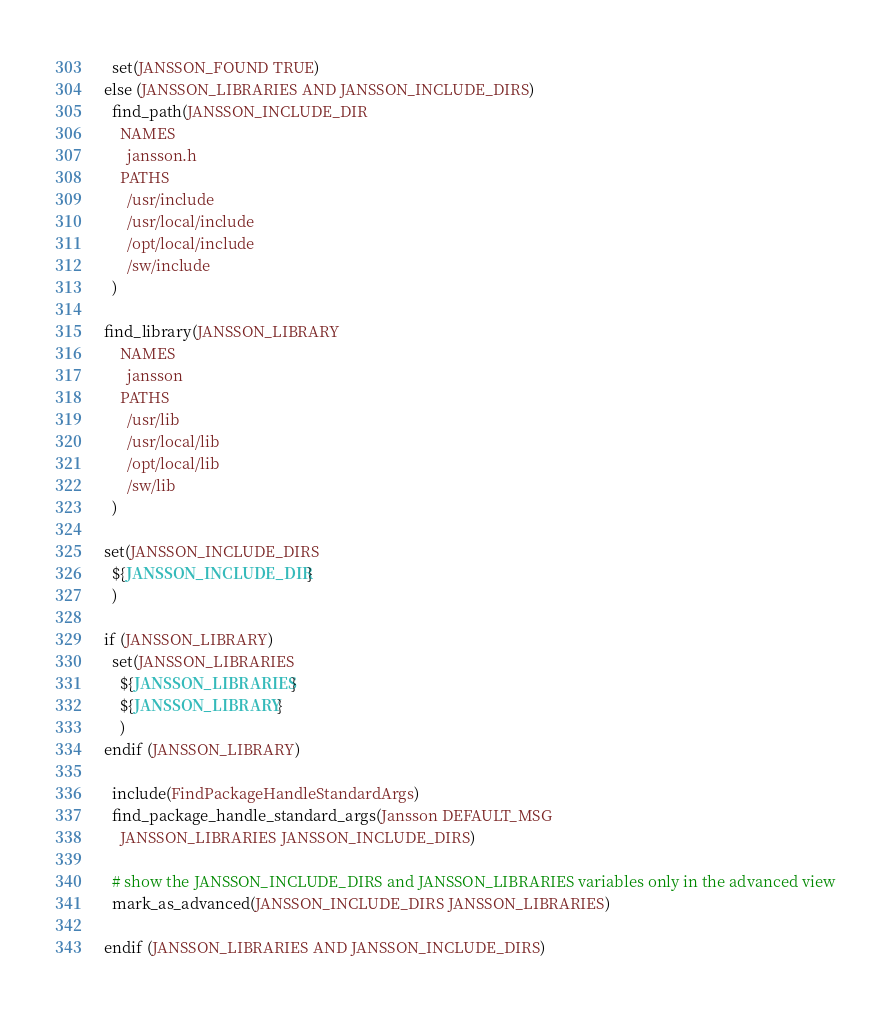Convert code to text. <code><loc_0><loc_0><loc_500><loc_500><_CMake_>  set(JANSSON_FOUND TRUE)
else (JANSSON_LIBRARIES AND JANSSON_INCLUDE_DIRS)
  find_path(JANSSON_INCLUDE_DIR
    NAMES
      jansson.h
    PATHS
      /usr/include
      /usr/local/include
      /opt/local/include
      /sw/include
  )

find_library(JANSSON_LIBRARY
    NAMES
      jansson
    PATHS
      /usr/lib
      /usr/local/lib
      /opt/local/lib
      /sw/lib
  )

set(JANSSON_INCLUDE_DIRS
  ${JANSSON_INCLUDE_DIR}
  )

if (JANSSON_LIBRARY)
  set(JANSSON_LIBRARIES
    ${JANSSON_LIBRARIES}
    ${JANSSON_LIBRARY}
    )
endif (JANSSON_LIBRARY)

  include(FindPackageHandleStandardArgs)
  find_package_handle_standard_args(Jansson DEFAULT_MSG
    JANSSON_LIBRARIES JANSSON_INCLUDE_DIRS)

  # show the JANSSON_INCLUDE_DIRS and JANSSON_LIBRARIES variables only in the advanced view
  mark_as_advanced(JANSSON_INCLUDE_DIRS JANSSON_LIBRARIES)

endif (JANSSON_LIBRARIES AND JANSSON_INCLUDE_DIRS)

</code> 